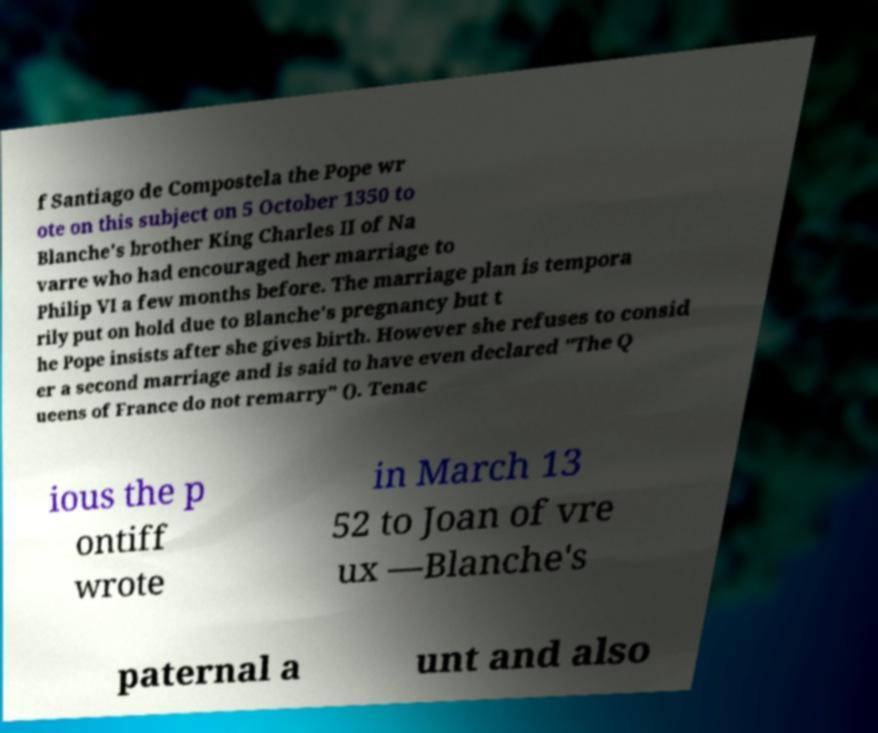For documentation purposes, I need the text within this image transcribed. Could you provide that? f Santiago de Compostela the Pope wr ote on this subject on 5 October 1350 to Blanche's brother King Charles II of Na varre who had encouraged her marriage to Philip VI a few months before. The marriage plan is tempora rily put on hold due to Blanche's pregnancy but t he Pope insists after she gives birth. However she refuses to consid er a second marriage and is said to have even declared "The Q ueens of France do not remarry" (). Tenac ious the p ontiff wrote in March 13 52 to Joan of vre ux —Blanche's paternal a unt and also 